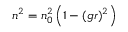Convert formula to latex. <formula><loc_0><loc_0><loc_500><loc_500>n ^ { 2 } = n _ { 0 } ^ { 2 } \left ( 1 - ( g r ) ^ { 2 } \right )</formula> 